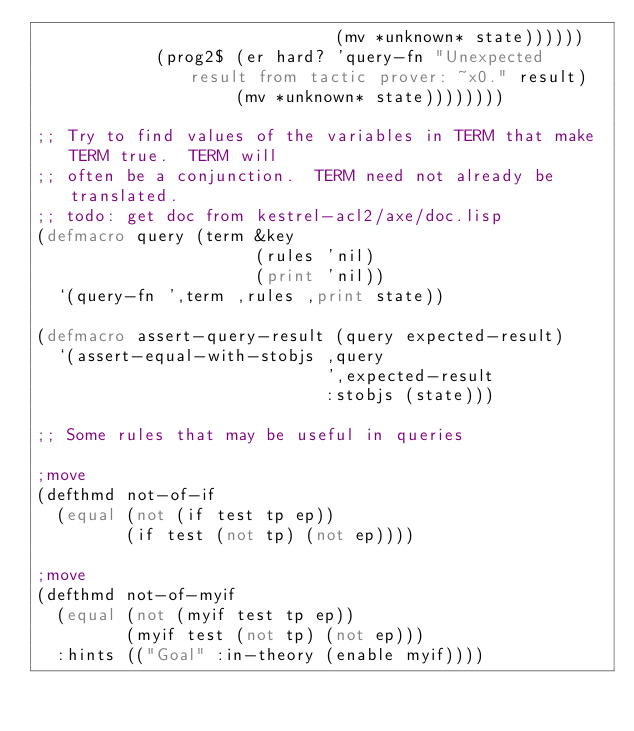Convert code to text. <code><loc_0><loc_0><loc_500><loc_500><_Lisp_>                              (mv *unknown* state))))))
            (prog2$ (er hard? 'query-fn "Unexpected result from tactic prover: ~x0." result)
                    (mv *unknown* state))))))))

;; Try to find values of the variables in TERM that make TERM true.  TERM will
;; often be a conjunction.  TERM need not already be translated.
;; todo: get doc from kestrel-acl2/axe/doc.lisp
(defmacro query (term &key
                      (rules 'nil)
                      (print 'nil))
  `(query-fn ',term ,rules ,print state))

(defmacro assert-query-result (query expected-result)
  `(assert-equal-with-stobjs ,query
                             ',expected-result
                             :stobjs (state)))

;; Some rules that may be useful in queries

;move
(defthmd not-of-if
  (equal (not (if test tp ep))
         (if test (not tp) (not ep))))

;move
(defthmd not-of-myif
  (equal (not (myif test tp ep))
         (myif test (not tp) (not ep)))
  :hints (("Goal" :in-theory (enable myif))))
</code> 